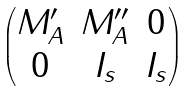<formula> <loc_0><loc_0><loc_500><loc_500>\begin{pmatrix} M ^ { \prime } _ { A } & M ^ { \prime \prime } _ { A } & 0 \\ 0 & I _ { s } & I _ { s } \end{pmatrix}</formula> 